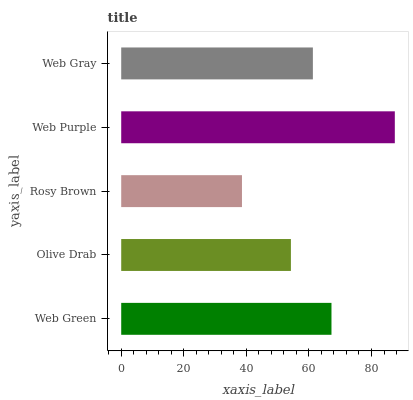Is Rosy Brown the minimum?
Answer yes or no. Yes. Is Web Purple the maximum?
Answer yes or no. Yes. Is Olive Drab the minimum?
Answer yes or no. No. Is Olive Drab the maximum?
Answer yes or no. No. Is Web Green greater than Olive Drab?
Answer yes or no. Yes. Is Olive Drab less than Web Green?
Answer yes or no. Yes. Is Olive Drab greater than Web Green?
Answer yes or no. No. Is Web Green less than Olive Drab?
Answer yes or no. No. Is Web Gray the high median?
Answer yes or no. Yes. Is Web Gray the low median?
Answer yes or no. Yes. Is Web Green the high median?
Answer yes or no. No. Is Olive Drab the low median?
Answer yes or no. No. 